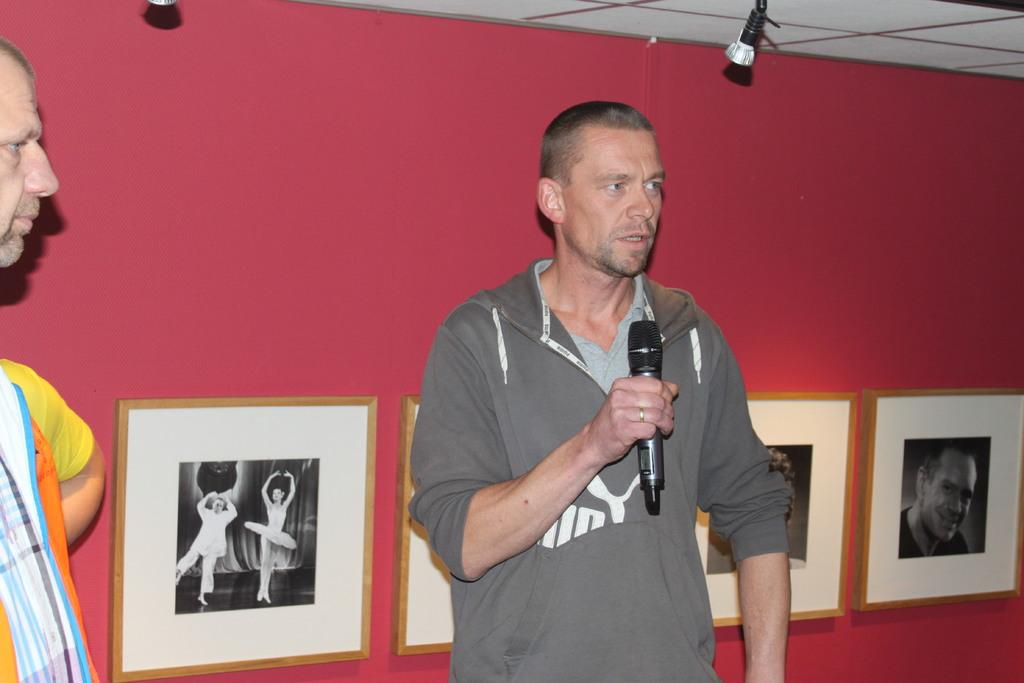How many people are in the image? There are people in the image, but the exact number is not specified. What is one person doing in the image? One person is holding a microphone. What can be seen on the wall in the background? There are frames attached to a pink wall in the background. What type of lighting is visible in the image? There are lights visible at the top of the image. What part of the room is visible in the image? The ceiling is visible in the image. What type of nerve is visible in the image? There is no nerve visible in the image. What kind of structure is being built by the people in the image? The image does not show people building any structure. 